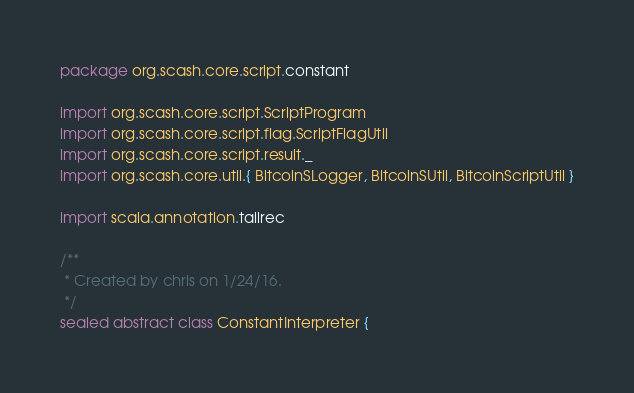Convert code to text. <code><loc_0><loc_0><loc_500><loc_500><_Scala_>package org.scash.core.script.constant

import org.scash.core.script.ScriptProgram
import org.scash.core.script.flag.ScriptFlagUtil
import org.scash.core.script.result._
import org.scash.core.util.{ BitcoinSLogger, BitcoinSUtil, BitcoinScriptUtil }

import scala.annotation.tailrec

/**
 * Created by chris on 1/24/16.
 */
sealed abstract class ConstantInterpreter {</code> 